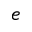<formula> <loc_0><loc_0><loc_500><loc_500>e</formula> 